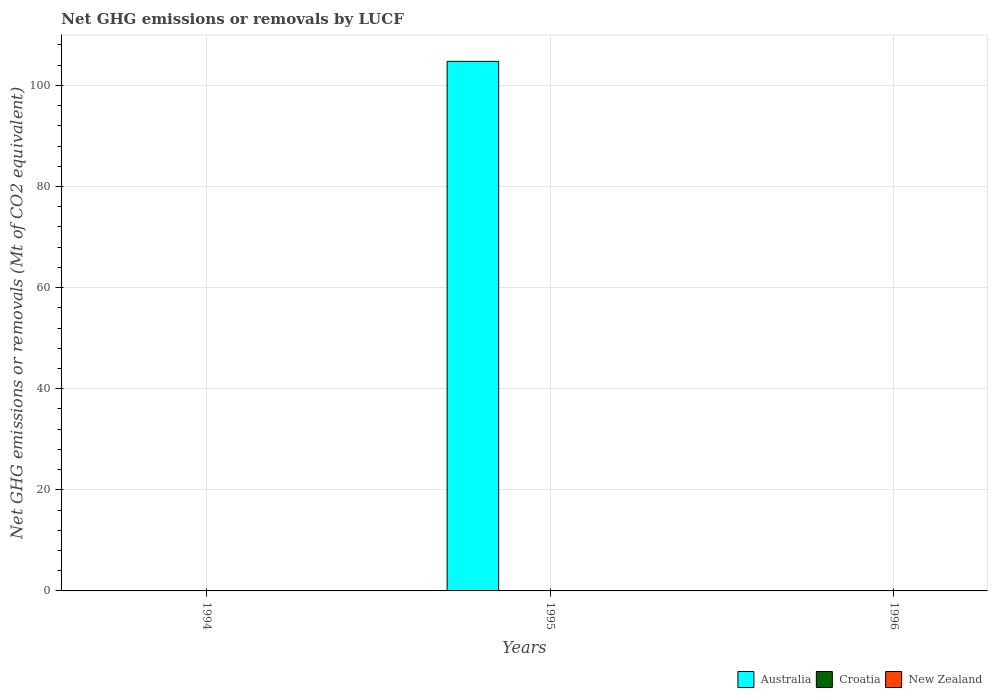How many different coloured bars are there?
Ensure brevity in your answer.  1. Are the number of bars per tick equal to the number of legend labels?
Provide a succinct answer. No. Are the number of bars on each tick of the X-axis equal?
Ensure brevity in your answer.  No. What is the label of the 3rd group of bars from the left?
Your answer should be compact. 1996. What is the net GHG emissions or removals by LUCF in Croatia in 1994?
Make the answer very short. 0. Across all years, what is the maximum net GHG emissions or removals by LUCF in Australia?
Keep it short and to the point. 104.75. Across all years, what is the minimum net GHG emissions or removals by LUCF in New Zealand?
Keep it short and to the point. 0. What is the total net GHG emissions or removals by LUCF in Croatia in the graph?
Keep it short and to the point. 0. What is the difference between the net GHG emissions or removals by LUCF in Croatia in 1996 and the net GHG emissions or removals by LUCF in Australia in 1994?
Provide a short and direct response. 0. What is the average net GHG emissions or removals by LUCF in New Zealand per year?
Keep it short and to the point. 0. What is the difference between the highest and the lowest net GHG emissions or removals by LUCF in Australia?
Provide a short and direct response. 104.75. In how many years, is the net GHG emissions or removals by LUCF in Australia greater than the average net GHG emissions or removals by LUCF in Australia taken over all years?
Provide a short and direct response. 1. Are all the bars in the graph horizontal?
Offer a terse response. No. How many years are there in the graph?
Your response must be concise. 3. What is the difference between two consecutive major ticks on the Y-axis?
Ensure brevity in your answer.  20. Does the graph contain any zero values?
Offer a terse response. Yes. Does the graph contain grids?
Provide a succinct answer. Yes. How many legend labels are there?
Offer a very short reply. 3. What is the title of the graph?
Your answer should be compact. Net GHG emissions or removals by LUCF. What is the label or title of the Y-axis?
Provide a succinct answer. Net GHG emissions or removals (Mt of CO2 equivalent). What is the Net GHG emissions or removals (Mt of CO2 equivalent) of Croatia in 1994?
Your answer should be compact. 0. What is the Net GHG emissions or removals (Mt of CO2 equivalent) of Australia in 1995?
Offer a very short reply. 104.75. What is the Net GHG emissions or removals (Mt of CO2 equivalent) in Croatia in 1995?
Ensure brevity in your answer.  0. What is the Net GHG emissions or removals (Mt of CO2 equivalent) in New Zealand in 1995?
Provide a succinct answer. 0. What is the Net GHG emissions or removals (Mt of CO2 equivalent) of Australia in 1996?
Offer a terse response. 0. What is the Net GHG emissions or removals (Mt of CO2 equivalent) in Croatia in 1996?
Provide a short and direct response. 0. What is the Net GHG emissions or removals (Mt of CO2 equivalent) in New Zealand in 1996?
Your answer should be very brief. 0. Across all years, what is the maximum Net GHG emissions or removals (Mt of CO2 equivalent) of Australia?
Your answer should be compact. 104.75. What is the total Net GHG emissions or removals (Mt of CO2 equivalent) of Australia in the graph?
Offer a terse response. 104.75. What is the total Net GHG emissions or removals (Mt of CO2 equivalent) of Croatia in the graph?
Your answer should be very brief. 0. What is the total Net GHG emissions or removals (Mt of CO2 equivalent) in New Zealand in the graph?
Keep it short and to the point. 0. What is the average Net GHG emissions or removals (Mt of CO2 equivalent) in Australia per year?
Your answer should be very brief. 34.92. What is the average Net GHG emissions or removals (Mt of CO2 equivalent) of Croatia per year?
Offer a very short reply. 0. What is the difference between the highest and the lowest Net GHG emissions or removals (Mt of CO2 equivalent) in Australia?
Your answer should be very brief. 104.75. 